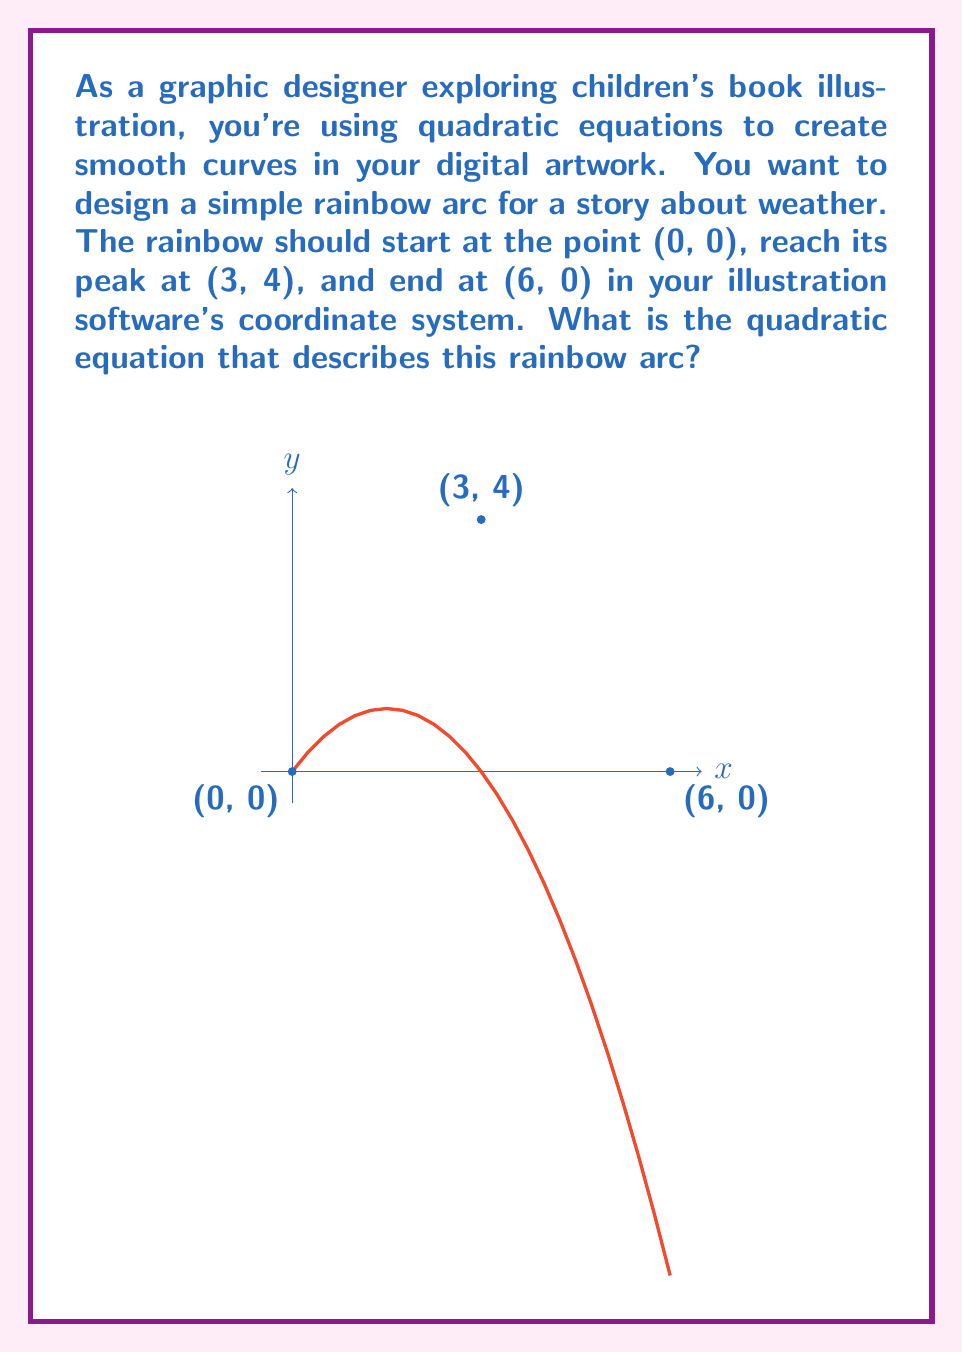Show me your answer to this math problem. Let's approach this step-by-step:

1) The general form of a quadratic equation is $y = ax^2 + bx + c$.

2) We know three points that the curve passes through:
   (0, 0), (3, 4), and (6, 0)

3) Let's substitute these points into the general equation:
   For (0, 0): $0 = a(0)^2 + b(0) + c$, so $c = 0$
   For (3, 4): $4 = 9a + 3b$
   For (6, 0): $0 = 36a + 6b$

4) From the last equation: $36a + 6b = 0$, or $6a + b = 0$, or $b = -6a$

5) Substitute this into the second equation:
   $4 = 9a + 3(-6a)$
   $4 = 9a - 18a = -9a$
   $a = -4/9$

6) If $a = -4/9$, then $b = -6(-4/9) = 8/3 = 4/3$

7) Therefore, the quadratic equation is:
   $y = -\frac{4}{9}x^2 + \frac{4}{3}x$
Answer: $y = -\frac{4}{9}x^2 + \frac{4}{3}x$ 